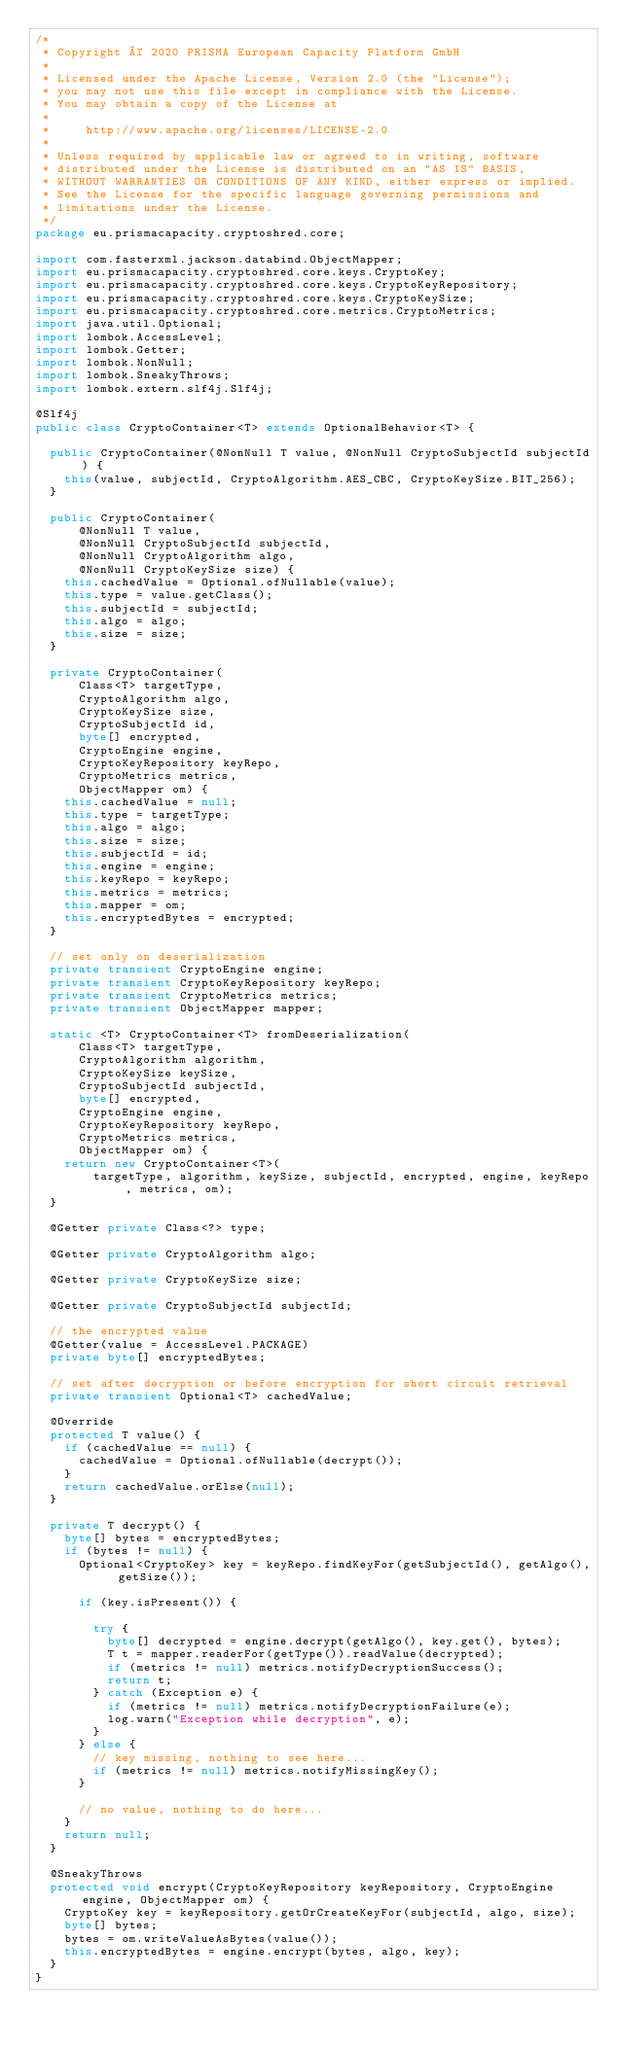<code> <loc_0><loc_0><loc_500><loc_500><_Java_>/*
 * Copyright © 2020 PRISMA European Capacity Platform GmbH
 *
 * Licensed under the Apache License, Version 2.0 (the "License");
 * you may not use this file except in compliance with the License.
 * You may obtain a copy of the License at
 *
 *     http://www.apache.org/licenses/LICENSE-2.0
 *
 * Unless required by applicable law or agreed to in writing, software
 * distributed under the License is distributed on an "AS IS" BASIS,
 * WITHOUT WARRANTIES OR CONDITIONS OF ANY KIND, either express or implied.
 * See the License for the specific language governing permissions and
 * limitations under the License.
 */
package eu.prismacapacity.cryptoshred.core;

import com.fasterxml.jackson.databind.ObjectMapper;
import eu.prismacapacity.cryptoshred.core.keys.CryptoKey;
import eu.prismacapacity.cryptoshred.core.keys.CryptoKeyRepository;
import eu.prismacapacity.cryptoshred.core.keys.CryptoKeySize;
import eu.prismacapacity.cryptoshred.core.metrics.CryptoMetrics;
import java.util.Optional;
import lombok.AccessLevel;
import lombok.Getter;
import lombok.NonNull;
import lombok.SneakyThrows;
import lombok.extern.slf4j.Slf4j;

@Slf4j
public class CryptoContainer<T> extends OptionalBehavior<T> {

  public CryptoContainer(@NonNull T value, @NonNull CryptoSubjectId subjectId) {
    this(value, subjectId, CryptoAlgorithm.AES_CBC, CryptoKeySize.BIT_256);
  }

  public CryptoContainer(
      @NonNull T value,
      @NonNull CryptoSubjectId subjectId,
      @NonNull CryptoAlgorithm algo,
      @NonNull CryptoKeySize size) {
    this.cachedValue = Optional.ofNullable(value);
    this.type = value.getClass();
    this.subjectId = subjectId;
    this.algo = algo;
    this.size = size;
  }

  private CryptoContainer(
      Class<T> targetType,
      CryptoAlgorithm algo,
      CryptoKeySize size,
      CryptoSubjectId id,
      byte[] encrypted,
      CryptoEngine engine,
      CryptoKeyRepository keyRepo,
      CryptoMetrics metrics,
      ObjectMapper om) {
    this.cachedValue = null;
    this.type = targetType;
    this.algo = algo;
    this.size = size;
    this.subjectId = id;
    this.engine = engine;
    this.keyRepo = keyRepo;
    this.metrics = metrics;
    this.mapper = om;
    this.encryptedBytes = encrypted;
  }

  // set only on deserialization
  private transient CryptoEngine engine;
  private transient CryptoKeyRepository keyRepo;
  private transient CryptoMetrics metrics;
  private transient ObjectMapper mapper;

  static <T> CryptoContainer<T> fromDeserialization(
      Class<T> targetType,
      CryptoAlgorithm algorithm,
      CryptoKeySize keySize,
      CryptoSubjectId subjectId,
      byte[] encrypted,
      CryptoEngine engine,
      CryptoKeyRepository keyRepo,
      CryptoMetrics metrics,
      ObjectMapper om) {
    return new CryptoContainer<T>(
        targetType, algorithm, keySize, subjectId, encrypted, engine, keyRepo, metrics, om);
  }

  @Getter private Class<?> type;

  @Getter private CryptoAlgorithm algo;

  @Getter private CryptoKeySize size;

  @Getter private CryptoSubjectId subjectId;

  // the encrypted value
  @Getter(value = AccessLevel.PACKAGE)
  private byte[] encryptedBytes;

  // set after decryption or before encryption for short circuit retrieval
  private transient Optional<T> cachedValue;

  @Override
  protected T value() {
    if (cachedValue == null) {
      cachedValue = Optional.ofNullable(decrypt());
    }
    return cachedValue.orElse(null);
  }

  private T decrypt() {
    byte[] bytes = encryptedBytes;
    if (bytes != null) {
      Optional<CryptoKey> key = keyRepo.findKeyFor(getSubjectId(), getAlgo(), getSize());

      if (key.isPresent()) {

        try {
          byte[] decrypted = engine.decrypt(getAlgo(), key.get(), bytes);
          T t = mapper.readerFor(getType()).readValue(decrypted);
          if (metrics != null) metrics.notifyDecryptionSuccess();
          return t;
        } catch (Exception e) {
          if (metrics != null) metrics.notifyDecryptionFailure(e);
          log.warn("Exception while decryption", e);
        }
      } else {
        // key missing, nothing to see here...
        if (metrics != null) metrics.notifyMissingKey();
      }

      // no value, nothing to do here...
    }
    return null;
  }

  @SneakyThrows
  protected void encrypt(CryptoKeyRepository keyRepository, CryptoEngine engine, ObjectMapper om) {
    CryptoKey key = keyRepository.getOrCreateKeyFor(subjectId, algo, size);
    byte[] bytes;
    bytes = om.writeValueAsBytes(value());
    this.encryptedBytes = engine.encrypt(bytes, algo, key);
  }
}
</code> 